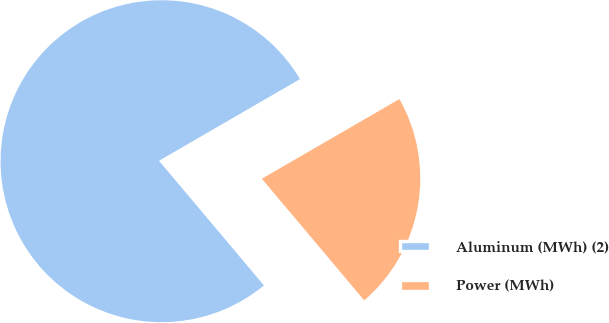Convert chart to OTSL. <chart><loc_0><loc_0><loc_500><loc_500><pie_chart><fcel>Aluminum (MWh) (2)<fcel>Power (MWh)<nl><fcel>77.78%<fcel>22.22%<nl></chart> 